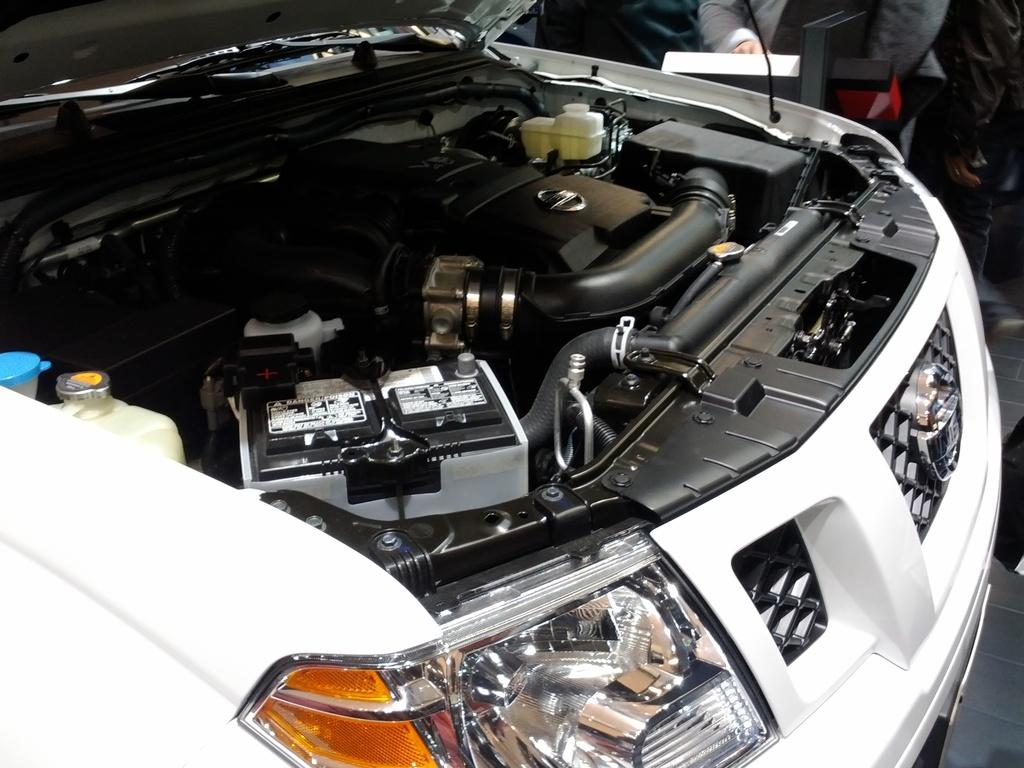What is the main subject of the picture? The main subject of the picture is the engine of a car. What color is the engine? The engine is black in color. What color is the car that the engine belongs to? The car is white in color. How much powder is on the girl's face in the image? There is no girl or powder present in the image; it features an engine of a car. 